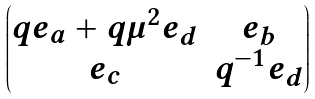<formula> <loc_0><loc_0><loc_500><loc_500>\begin{pmatrix} q e _ { a } + q \mu ^ { 2 } e _ { d } & e _ { b } \\ e _ { c } & q ^ { - 1 } e _ { d } \end{pmatrix}</formula> 